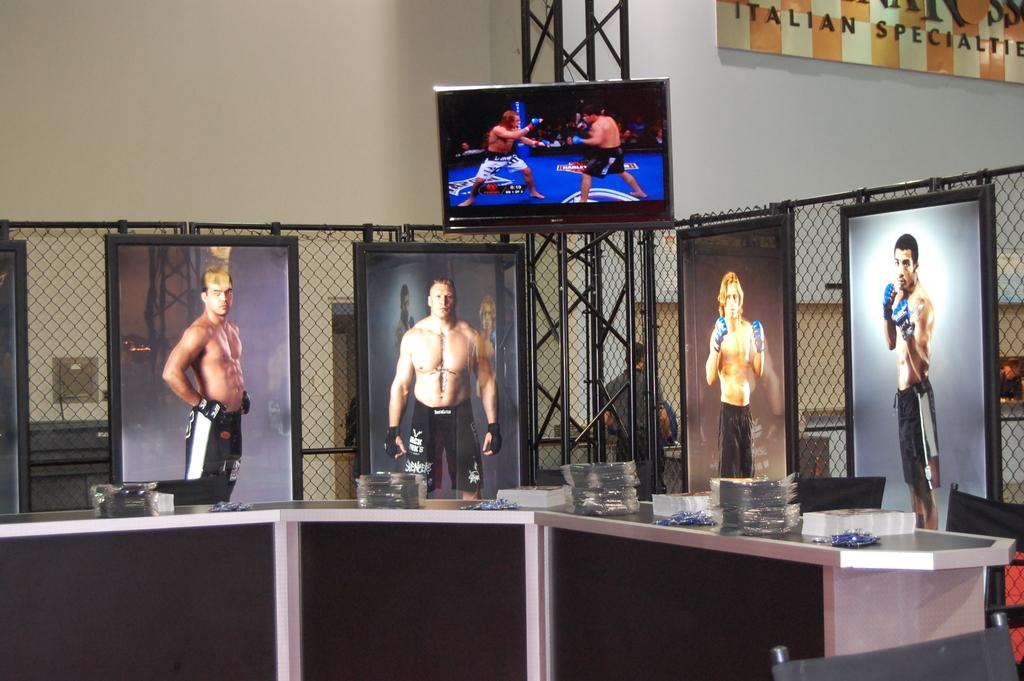What objects can be seen in the image that are used for displaying photos? There are photo frames in the image. What piece of furniture is present in the image that is commonly used for placing objects? There is a table in the image. What items can be seen on the table in the image? There are items on the table, but the specific items are not mentioned in the facts. What electronic device is visible in the image? There is a television in the image. What object in the image contains text? There is a board with text in the image. Can you describe the man in the background of the image? There is a man standing in the background of the image, but no specific details about his appearance or actions are provided in the facts. What type of cracker is being used as a lamp in the image? There is no cracker or lamp present in the image. What punishment is being administered to the man in the background of the image? There is no indication of any punishment being administered to the man in the image. 